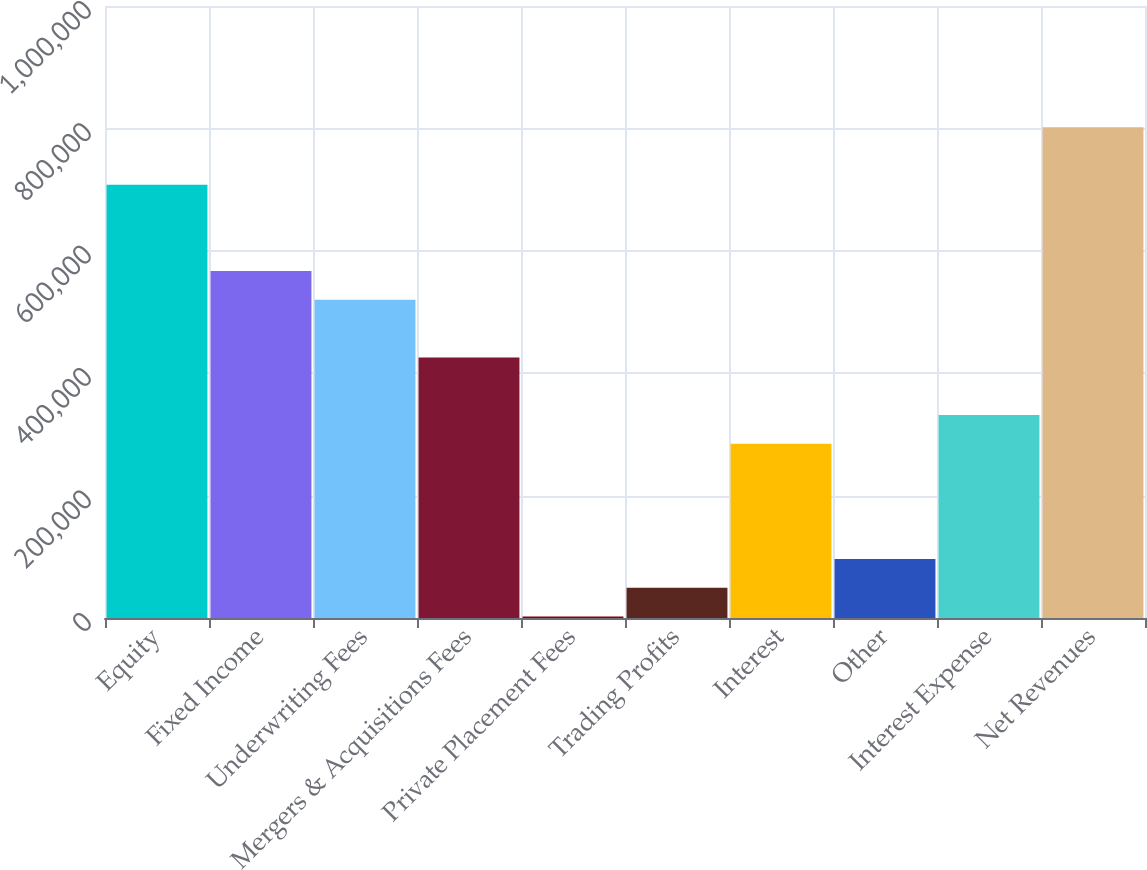<chart> <loc_0><loc_0><loc_500><loc_500><bar_chart><fcel>Equity<fcel>Fixed Income<fcel>Underwriting Fees<fcel>Mergers & Acquisitions Fees<fcel>Private Placement Fees<fcel>Trading Profits<fcel>Interest<fcel>Other<fcel>Interest Expense<fcel>Net Revenues<nl><fcel>707964<fcel>566878<fcel>519850<fcel>425792<fcel>2536<fcel>49564.5<fcel>284707<fcel>96593<fcel>331736<fcel>802020<nl></chart> 